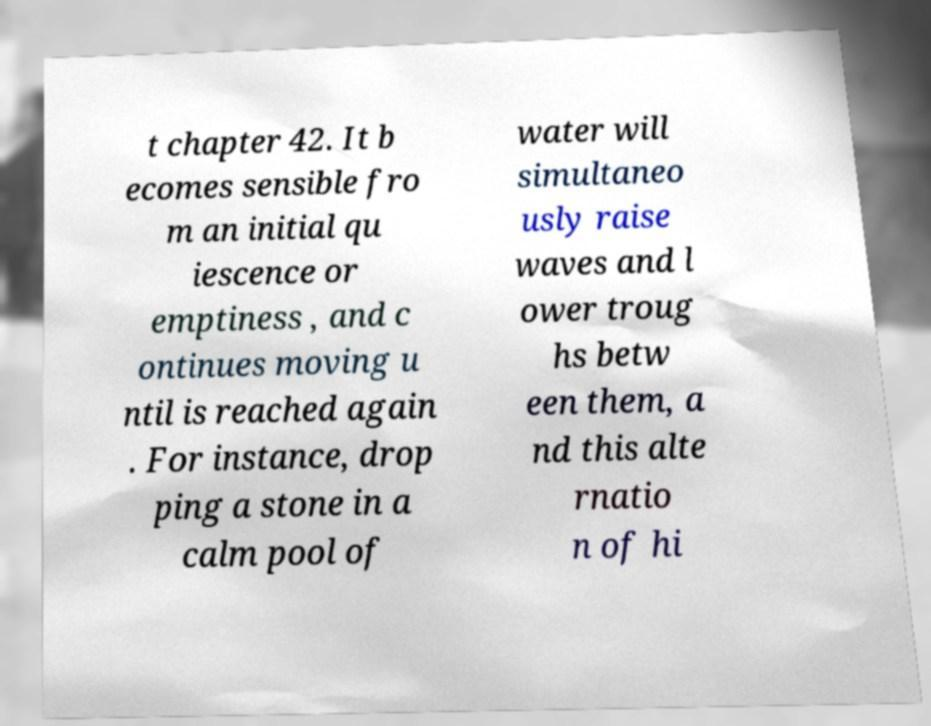There's text embedded in this image that I need extracted. Can you transcribe it verbatim? t chapter 42. It b ecomes sensible fro m an initial qu iescence or emptiness , and c ontinues moving u ntil is reached again . For instance, drop ping a stone in a calm pool of water will simultaneo usly raise waves and l ower troug hs betw een them, a nd this alte rnatio n of hi 